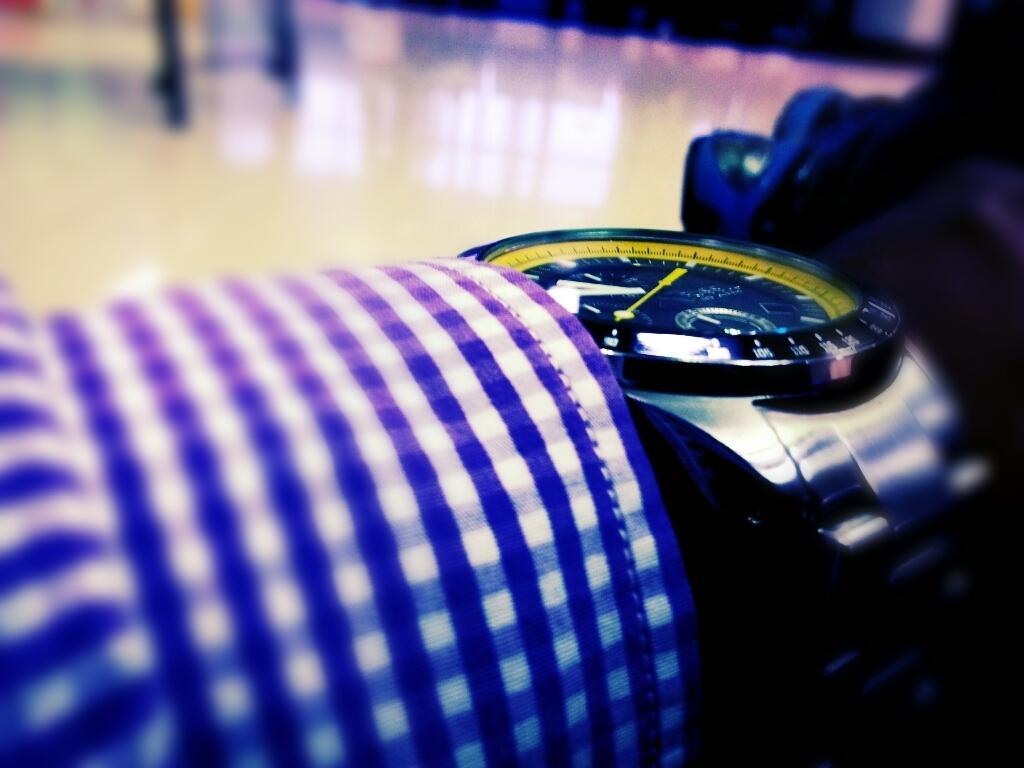Please provide a concise description of this image. In the foreground of this picture we can see a watch and a cloth. In the background we can see some other objects. 